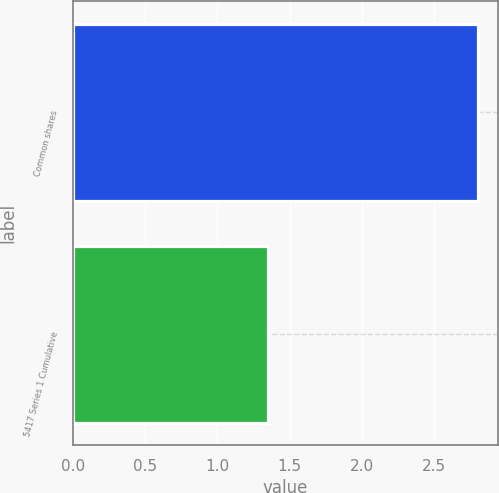Convert chart. <chart><loc_0><loc_0><loc_500><loc_500><bar_chart><fcel>Common shares<fcel>5417 Series 1 Cumulative<nl><fcel>2.8<fcel>1.35<nl></chart> 